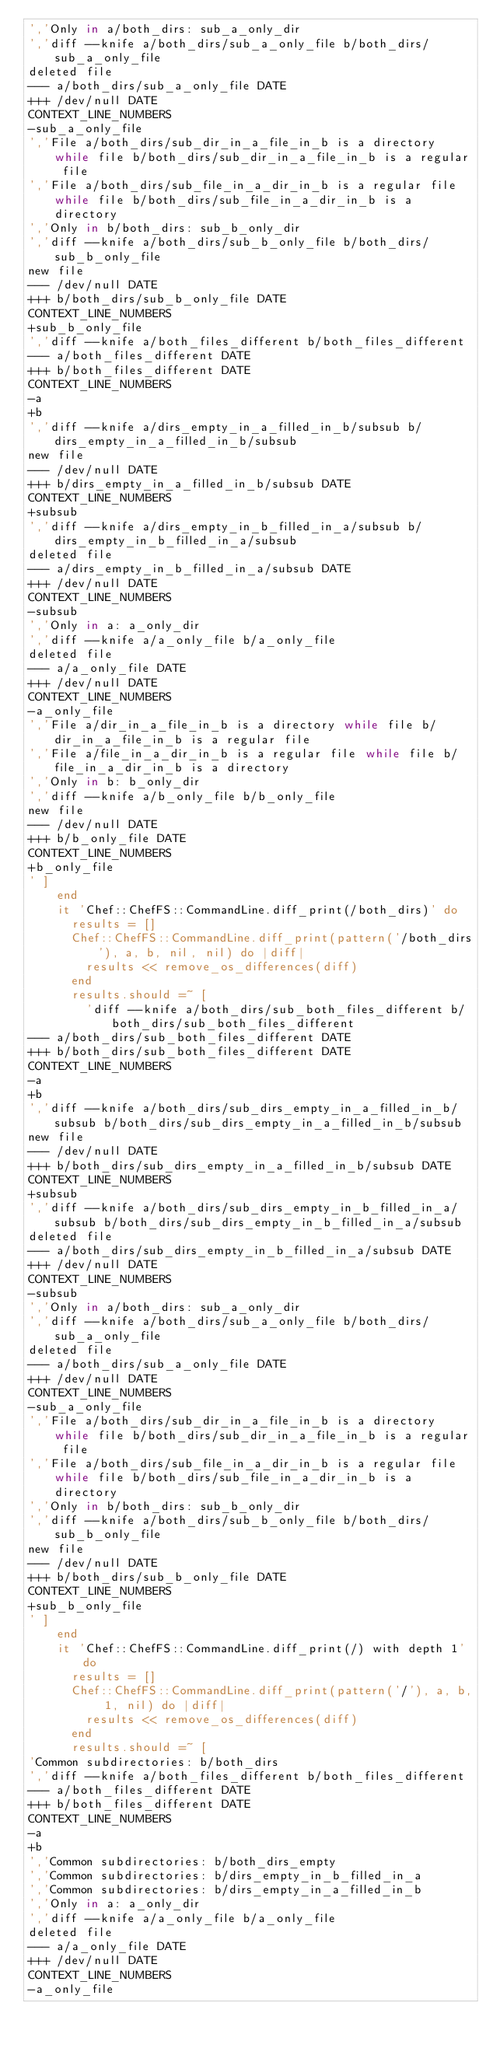<code> <loc_0><loc_0><loc_500><loc_500><_Ruby_>','Only in a/both_dirs: sub_a_only_dir
','diff --knife a/both_dirs/sub_a_only_file b/both_dirs/sub_a_only_file
deleted file
--- a/both_dirs/sub_a_only_file DATE
+++ /dev/null DATE
CONTEXT_LINE_NUMBERS
-sub_a_only_file
','File a/both_dirs/sub_dir_in_a_file_in_b is a directory while file b/both_dirs/sub_dir_in_a_file_in_b is a regular file
','File a/both_dirs/sub_file_in_a_dir_in_b is a regular file while file b/both_dirs/sub_file_in_a_dir_in_b is a directory
','Only in b/both_dirs: sub_b_only_dir
','diff --knife a/both_dirs/sub_b_only_file b/both_dirs/sub_b_only_file
new file
--- /dev/null DATE
+++ b/both_dirs/sub_b_only_file DATE
CONTEXT_LINE_NUMBERS
+sub_b_only_file
','diff --knife a/both_files_different b/both_files_different
--- a/both_files_different DATE
+++ b/both_files_different DATE
CONTEXT_LINE_NUMBERS
-a
+b
','diff --knife a/dirs_empty_in_a_filled_in_b/subsub b/dirs_empty_in_a_filled_in_b/subsub
new file
--- /dev/null DATE
+++ b/dirs_empty_in_a_filled_in_b/subsub DATE
CONTEXT_LINE_NUMBERS
+subsub
','diff --knife a/dirs_empty_in_b_filled_in_a/subsub b/dirs_empty_in_b_filled_in_a/subsub
deleted file
--- a/dirs_empty_in_b_filled_in_a/subsub DATE
+++ /dev/null DATE
CONTEXT_LINE_NUMBERS
-subsub
','Only in a: a_only_dir
','diff --knife a/a_only_file b/a_only_file
deleted file
--- a/a_only_file DATE
+++ /dev/null DATE
CONTEXT_LINE_NUMBERS
-a_only_file
','File a/dir_in_a_file_in_b is a directory while file b/dir_in_a_file_in_b is a regular file
','File a/file_in_a_dir_in_b is a regular file while file b/file_in_a_dir_in_b is a directory
','Only in b: b_only_dir
','diff --knife a/b_only_file b/b_only_file
new file
--- /dev/null DATE
+++ b/b_only_file DATE
CONTEXT_LINE_NUMBERS
+b_only_file
' ]
    end
    it 'Chef::ChefFS::CommandLine.diff_print(/both_dirs)' do
      results = []
      Chef::ChefFS::CommandLine.diff_print(pattern('/both_dirs'), a, b, nil, nil) do |diff|
        results << remove_os_differences(diff)
      end
      results.should =~ [
        'diff --knife a/both_dirs/sub_both_files_different b/both_dirs/sub_both_files_different
--- a/both_dirs/sub_both_files_different DATE
+++ b/both_dirs/sub_both_files_different DATE
CONTEXT_LINE_NUMBERS
-a
+b
','diff --knife a/both_dirs/sub_dirs_empty_in_a_filled_in_b/subsub b/both_dirs/sub_dirs_empty_in_a_filled_in_b/subsub
new file
--- /dev/null DATE
+++ b/both_dirs/sub_dirs_empty_in_a_filled_in_b/subsub DATE
CONTEXT_LINE_NUMBERS
+subsub
','diff --knife a/both_dirs/sub_dirs_empty_in_b_filled_in_a/subsub b/both_dirs/sub_dirs_empty_in_b_filled_in_a/subsub
deleted file
--- a/both_dirs/sub_dirs_empty_in_b_filled_in_a/subsub DATE
+++ /dev/null DATE
CONTEXT_LINE_NUMBERS
-subsub
','Only in a/both_dirs: sub_a_only_dir
','diff --knife a/both_dirs/sub_a_only_file b/both_dirs/sub_a_only_file
deleted file
--- a/both_dirs/sub_a_only_file DATE
+++ /dev/null DATE
CONTEXT_LINE_NUMBERS
-sub_a_only_file
','File a/both_dirs/sub_dir_in_a_file_in_b is a directory while file b/both_dirs/sub_dir_in_a_file_in_b is a regular file
','File a/both_dirs/sub_file_in_a_dir_in_b is a regular file while file b/both_dirs/sub_file_in_a_dir_in_b is a directory
','Only in b/both_dirs: sub_b_only_dir
','diff --knife a/both_dirs/sub_b_only_file b/both_dirs/sub_b_only_file
new file
--- /dev/null DATE
+++ b/both_dirs/sub_b_only_file DATE
CONTEXT_LINE_NUMBERS
+sub_b_only_file
' ]
    end
    it 'Chef::ChefFS::CommandLine.diff_print(/) with depth 1' do
      results = []
      Chef::ChefFS::CommandLine.diff_print(pattern('/'), a, b, 1, nil) do |diff|
        results << remove_os_differences(diff)
      end
      results.should =~ [
'Common subdirectories: b/both_dirs
','diff --knife a/both_files_different b/both_files_different
--- a/both_files_different DATE
+++ b/both_files_different DATE
CONTEXT_LINE_NUMBERS
-a
+b
','Common subdirectories: b/both_dirs_empty
','Common subdirectories: b/dirs_empty_in_b_filled_in_a
','Common subdirectories: b/dirs_empty_in_a_filled_in_b
','Only in a: a_only_dir
','diff --knife a/a_only_file b/a_only_file
deleted file
--- a/a_only_file DATE
+++ /dev/null DATE
CONTEXT_LINE_NUMBERS
-a_only_file</code> 